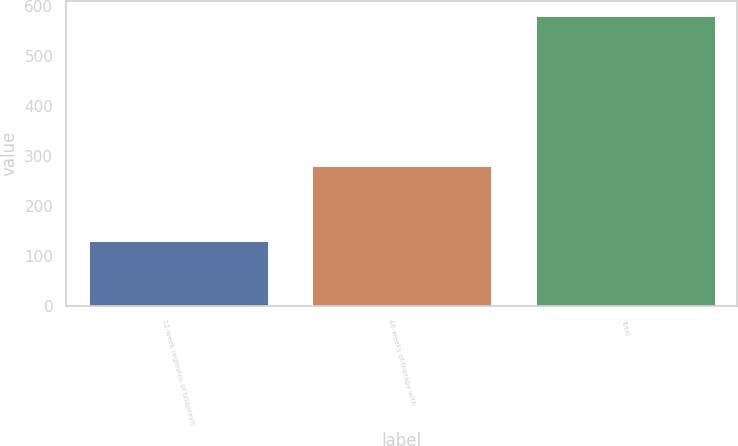Convert chart. <chart><loc_0><loc_0><loc_500><loc_500><bar_chart><fcel>12-week regimens of telaprevir<fcel>48-weeks of therapy with<fcel>Total<nl><fcel>130<fcel>280<fcel>580<nl></chart> 